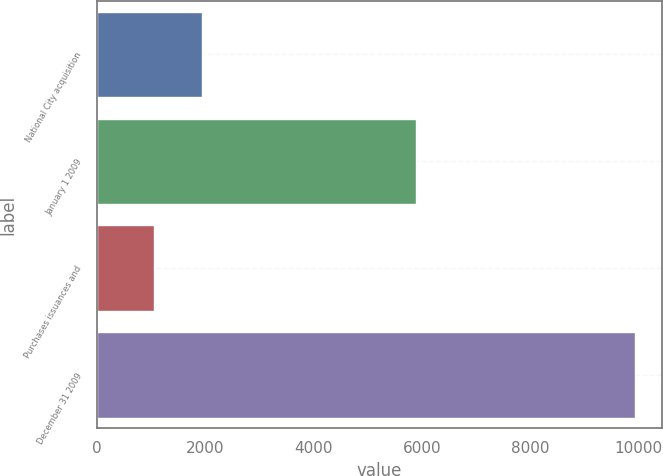Convert chart to OTSL. <chart><loc_0><loc_0><loc_500><loc_500><bar_chart><fcel>National City acquisition<fcel>January 1 2009<fcel>Purchases issuances and<fcel>December 31 2009<nl><fcel>1938.3<fcel>5900<fcel>1050<fcel>9933<nl></chart> 